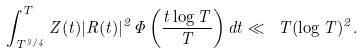Convert formula to latex. <formula><loc_0><loc_0><loc_500><loc_500>\int _ { T ^ { 3 / 4 } } ^ { T } Z ( t ) | R ( t ) | ^ { 2 } \Phi \left ( \frac { t \log T } { T } \right ) d t \ll \L \ T ( \log T ) ^ { 2 } .</formula> 